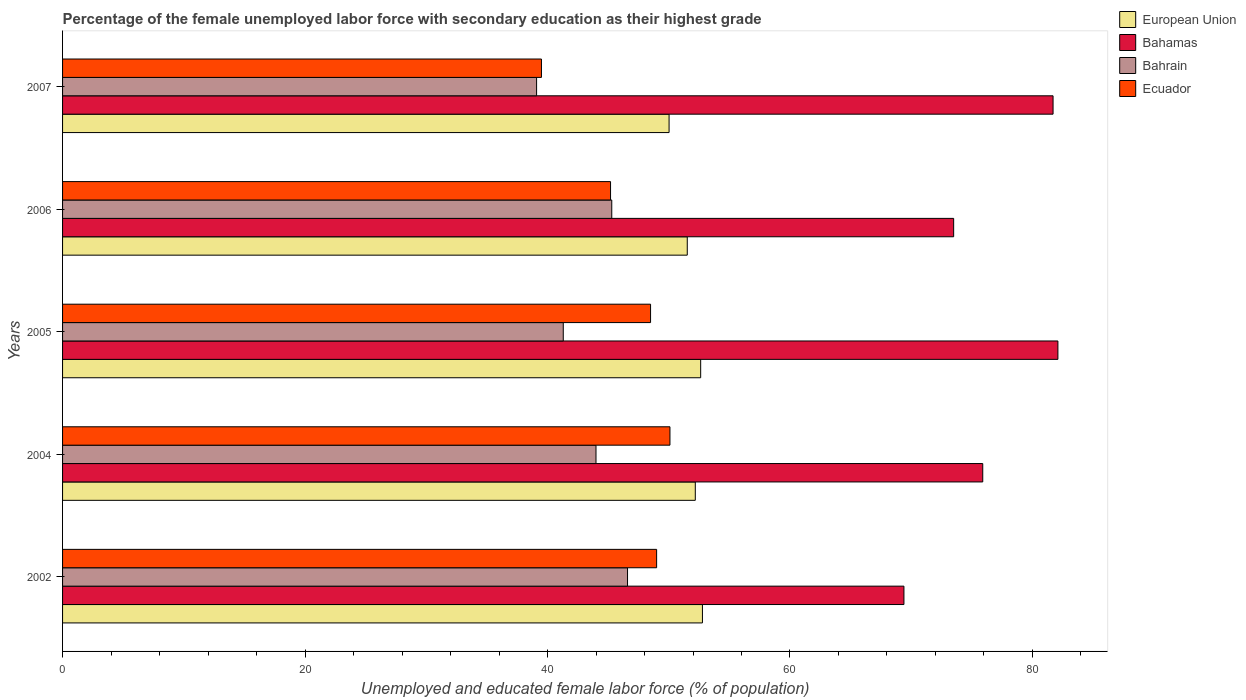How many different coloured bars are there?
Your answer should be compact. 4. Are the number of bars per tick equal to the number of legend labels?
Your response must be concise. Yes. How many bars are there on the 4th tick from the top?
Make the answer very short. 4. How many bars are there on the 3rd tick from the bottom?
Your answer should be very brief. 4. What is the label of the 3rd group of bars from the top?
Keep it short and to the point. 2005. In how many cases, is the number of bars for a given year not equal to the number of legend labels?
Keep it short and to the point. 0. What is the percentage of the unemployed female labor force with secondary education in Bahamas in 2004?
Your answer should be compact. 75.9. Across all years, what is the maximum percentage of the unemployed female labor force with secondary education in Bahamas?
Provide a succinct answer. 82.1. Across all years, what is the minimum percentage of the unemployed female labor force with secondary education in Bahrain?
Give a very brief answer. 39.1. In which year was the percentage of the unemployed female labor force with secondary education in Bahamas maximum?
Give a very brief answer. 2005. In which year was the percentage of the unemployed female labor force with secondary education in Bahrain minimum?
Offer a terse response. 2007. What is the total percentage of the unemployed female labor force with secondary education in European Union in the graph?
Keep it short and to the point. 259.16. What is the difference between the percentage of the unemployed female labor force with secondary education in European Union in 2005 and that in 2006?
Provide a succinct answer. 1.11. What is the difference between the percentage of the unemployed female labor force with secondary education in Bahrain in 2004 and the percentage of the unemployed female labor force with secondary education in European Union in 2007?
Keep it short and to the point. -6.03. What is the average percentage of the unemployed female labor force with secondary education in Bahamas per year?
Provide a succinct answer. 76.52. In the year 2004, what is the difference between the percentage of the unemployed female labor force with secondary education in Bahamas and percentage of the unemployed female labor force with secondary education in European Union?
Give a very brief answer. 23.71. In how many years, is the percentage of the unemployed female labor force with secondary education in Bahamas greater than 40 %?
Your response must be concise. 5. What is the ratio of the percentage of the unemployed female labor force with secondary education in European Union in 2004 to that in 2006?
Your answer should be compact. 1.01. Is the percentage of the unemployed female labor force with secondary education in European Union in 2002 less than that in 2005?
Your answer should be very brief. No. Is the difference between the percentage of the unemployed female labor force with secondary education in Bahamas in 2002 and 2005 greater than the difference between the percentage of the unemployed female labor force with secondary education in European Union in 2002 and 2005?
Provide a succinct answer. No. What is the difference between the highest and the second highest percentage of the unemployed female labor force with secondary education in Bahrain?
Make the answer very short. 1.3. What is the difference between the highest and the lowest percentage of the unemployed female labor force with secondary education in European Union?
Your answer should be compact. 2.75. In how many years, is the percentage of the unemployed female labor force with secondary education in Bahrain greater than the average percentage of the unemployed female labor force with secondary education in Bahrain taken over all years?
Provide a succinct answer. 3. What does the 2nd bar from the top in 2006 represents?
Make the answer very short. Bahrain. What does the 2nd bar from the bottom in 2005 represents?
Your answer should be compact. Bahamas. Are all the bars in the graph horizontal?
Your response must be concise. Yes. How many years are there in the graph?
Your answer should be compact. 5. What is the difference between two consecutive major ticks on the X-axis?
Make the answer very short. 20. Where does the legend appear in the graph?
Your answer should be compact. Top right. How many legend labels are there?
Make the answer very short. 4. How are the legend labels stacked?
Provide a short and direct response. Vertical. What is the title of the graph?
Your answer should be compact. Percentage of the female unemployed labor force with secondary education as their highest grade. Does "Luxembourg" appear as one of the legend labels in the graph?
Your response must be concise. No. What is the label or title of the X-axis?
Your answer should be compact. Unemployed and educated female labor force (% of population). What is the label or title of the Y-axis?
Your response must be concise. Years. What is the Unemployed and educated female labor force (% of population) of European Union in 2002?
Your answer should be very brief. 52.78. What is the Unemployed and educated female labor force (% of population) of Bahamas in 2002?
Offer a terse response. 69.4. What is the Unemployed and educated female labor force (% of population) in Bahrain in 2002?
Provide a succinct answer. 46.6. What is the Unemployed and educated female labor force (% of population) of Ecuador in 2002?
Your answer should be very brief. 49. What is the Unemployed and educated female labor force (% of population) of European Union in 2004?
Give a very brief answer. 52.19. What is the Unemployed and educated female labor force (% of population) of Bahamas in 2004?
Offer a very short reply. 75.9. What is the Unemployed and educated female labor force (% of population) of Bahrain in 2004?
Give a very brief answer. 44. What is the Unemployed and educated female labor force (% of population) of Ecuador in 2004?
Your answer should be very brief. 50.1. What is the Unemployed and educated female labor force (% of population) of European Union in 2005?
Offer a terse response. 52.63. What is the Unemployed and educated female labor force (% of population) of Bahamas in 2005?
Ensure brevity in your answer.  82.1. What is the Unemployed and educated female labor force (% of population) of Bahrain in 2005?
Provide a succinct answer. 41.3. What is the Unemployed and educated female labor force (% of population) in Ecuador in 2005?
Make the answer very short. 48.5. What is the Unemployed and educated female labor force (% of population) in European Union in 2006?
Offer a very short reply. 51.53. What is the Unemployed and educated female labor force (% of population) of Bahamas in 2006?
Provide a short and direct response. 73.5. What is the Unemployed and educated female labor force (% of population) of Bahrain in 2006?
Your answer should be very brief. 45.3. What is the Unemployed and educated female labor force (% of population) in Ecuador in 2006?
Your answer should be very brief. 45.2. What is the Unemployed and educated female labor force (% of population) of European Union in 2007?
Your answer should be very brief. 50.03. What is the Unemployed and educated female labor force (% of population) in Bahamas in 2007?
Offer a very short reply. 81.7. What is the Unemployed and educated female labor force (% of population) of Bahrain in 2007?
Your answer should be very brief. 39.1. What is the Unemployed and educated female labor force (% of population) of Ecuador in 2007?
Keep it short and to the point. 39.5. Across all years, what is the maximum Unemployed and educated female labor force (% of population) in European Union?
Provide a succinct answer. 52.78. Across all years, what is the maximum Unemployed and educated female labor force (% of population) of Bahamas?
Ensure brevity in your answer.  82.1. Across all years, what is the maximum Unemployed and educated female labor force (% of population) in Bahrain?
Ensure brevity in your answer.  46.6. Across all years, what is the maximum Unemployed and educated female labor force (% of population) in Ecuador?
Offer a very short reply. 50.1. Across all years, what is the minimum Unemployed and educated female labor force (% of population) of European Union?
Provide a short and direct response. 50.03. Across all years, what is the minimum Unemployed and educated female labor force (% of population) of Bahamas?
Your answer should be very brief. 69.4. Across all years, what is the minimum Unemployed and educated female labor force (% of population) in Bahrain?
Offer a terse response. 39.1. Across all years, what is the minimum Unemployed and educated female labor force (% of population) in Ecuador?
Give a very brief answer. 39.5. What is the total Unemployed and educated female labor force (% of population) of European Union in the graph?
Your answer should be compact. 259.16. What is the total Unemployed and educated female labor force (% of population) of Bahamas in the graph?
Your answer should be very brief. 382.6. What is the total Unemployed and educated female labor force (% of population) of Bahrain in the graph?
Offer a terse response. 216.3. What is the total Unemployed and educated female labor force (% of population) of Ecuador in the graph?
Your answer should be very brief. 232.3. What is the difference between the Unemployed and educated female labor force (% of population) in European Union in 2002 and that in 2004?
Keep it short and to the point. 0.59. What is the difference between the Unemployed and educated female labor force (% of population) of Bahamas in 2002 and that in 2004?
Ensure brevity in your answer.  -6.5. What is the difference between the Unemployed and educated female labor force (% of population) of Bahrain in 2002 and that in 2004?
Give a very brief answer. 2.6. What is the difference between the Unemployed and educated female labor force (% of population) in European Union in 2002 and that in 2005?
Provide a short and direct response. 0.15. What is the difference between the Unemployed and educated female labor force (% of population) of Bahrain in 2002 and that in 2005?
Your answer should be compact. 5.3. What is the difference between the Unemployed and educated female labor force (% of population) in Ecuador in 2002 and that in 2005?
Offer a very short reply. 0.5. What is the difference between the Unemployed and educated female labor force (% of population) in European Union in 2002 and that in 2006?
Provide a succinct answer. 1.25. What is the difference between the Unemployed and educated female labor force (% of population) in Ecuador in 2002 and that in 2006?
Your answer should be very brief. 3.8. What is the difference between the Unemployed and educated female labor force (% of population) of European Union in 2002 and that in 2007?
Your answer should be very brief. 2.75. What is the difference between the Unemployed and educated female labor force (% of population) in Bahamas in 2002 and that in 2007?
Offer a terse response. -12.3. What is the difference between the Unemployed and educated female labor force (% of population) in Bahrain in 2002 and that in 2007?
Offer a terse response. 7.5. What is the difference between the Unemployed and educated female labor force (% of population) of European Union in 2004 and that in 2005?
Keep it short and to the point. -0.44. What is the difference between the Unemployed and educated female labor force (% of population) of Bahamas in 2004 and that in 2005?
Your answer should be compact. -6.2. What is the difference between the Unemployed and educated female labor force (% of population) in Bahrain in 2004 and that in 2005?
Provide a succinct answer. 2.7. What is the difference between the Unemployed and educated female labor force (% of population) in European Union in 2004 and that in 2006?
Ensure brevity in your answer.  0.66. What is the difference between the Unemployed and educated female labor force (% of population) in Bahamas in 2004 and that in 2006?
Your answer should be compact. 2.4. What is the difference between the Unemployed and educated female labor force (% of population) in Ecuador in 2004 and that in 2006?
Your response must be concise. 4.9. What is the difference between the Unemployed and educated female labor force (% of population) of European Union in 2004 and that in 2007?
Provide a short and direct response. 2.16. What is the difference between the Unemployed and educated female labor force (% of population) in Bahamas in 2004 and that in 2007?
Offer a very short reply. -5.8. What is the difference between the Unemployed and educated female labor force (% of population) of Bahrain in 2004 and that in 2007?
Keep it short and to the point. 4.9. What is the difference between the Unemployed and educated female labor force (% of population) of European Union in 2005 and that in 2006?
Provide a succinct answer. 1.11. What is the difference between the Unemployed and educated female labor force (% of population) of Bahamas in 2005 and that in 2006?
Make the answer very short. 8.6. What is the difference between the Unemployed and educated female labor force (% of population) in Bahrain in 2005 and that in 2006?
Give a very brief answer. -4. What is the difference between the Unemployed and educated female labor force (% of population) of European Union in 2005 and that in 2007?
Ensure brevity in your answer.  2.61. What is the difference between the Unemployed and educated female labor force (% of population) of Bahamas in 2005 and that in 2007?
Your response must be concise. 0.4. What is the difference between the Unemployed and educated female labor force (% of population) in European Union in 2002 and the Unemployed and educated female labor force (% of population) in Bahamas in 2004?
Your answer should be compact. -23.12. What is the difference between the Unemployed and educated female labor force (% of population) in European Union in 2002 and the Unemployed and educated female labor force (% of population) in Bahrain in 2004?
Your answer should be very brief. 8.78. What is the difference between the Unemployed and educated female labor force (% of population) in European Union in 2002 and the Unemployed and educated female labor force (% of population) in Ecuador in 2004?
Give a very brief answer. 2.68. What is the difference between the Unemployed and educated female labor force (% of population) of Bahamas in 2002 and the Unemployed and educated female labor force (% of population) of Bahrain in 2004?
Ensure brevity in your answer.  25.4. What is the difference between the Unemployed and educated female labor force (% of population) in Bahamas in 2002 and the Unemployed and educated female labor force (% of population) in Ecuador in 2004?
Ensure brevity in your answer.  19.3. What is the difference between the Unemployed and educated female labor force (% of population) in European Union in 2002 and the Unemployed and educated female labor force (% of population) in Bahamas in 2005?
Your response must be concise. -29.32. What is the difference between the Unemployed and educated female labor force (% of population) of European Union in 2002 and the Unemployed and educated female labor force (% of population) of Bahrain in 2005?
Your answer should be compact. 11.48. What is the difference between the Unemployed and educated female labor force (% of population) in European Union in 2002 and the Unemployed and educated female labor force (% of population) in Ecuador in 2005?
Give a very brief answer. 4.28. What is the difference between the Unemployed and educated female labor force (% of population) in Bahamas in 2002 and the Unemployed and educated female labor force (% of population) in Bahrain in 2005?
Make the answer very short. 28.1. What is the difference between the Unemployed and educated female labor force (% of population) in Bahamas in 2002 and the Unemployed and educated female labor force (% of population) in Ecuador in 2005?
Give a very brief answer. 20.9. What is the difference between the Unemployed and educated female labor force (% of population) in Bahrain in 2002 and the Unemployed and educated female labor force (% of population) in Ecuador in 2005?
Ensure brevity in your answer.  -1.9. What is the difference between the Unemployed and educated female labor force (% of population) in European Union in 2002 and the Unemployed and educated female labor force (% of population) in Bahamas in 2006?
Offer a terse response. -20.72. What is the difference between the Unemployed and educated female labor force (% of population) in European Union in 2002 and the Unemployed and educated female labor force (% of population) in Bahrain in 2006?
Your answer should be very brief. 7.48. What is the difference between the Unemployed and educated female labor force (% of population) of European Union in 2002 and the Unemployed and educated female labor force (% of population) of Ecuador in 2006?
Your answer should be very brief. 7.58. What is the difference between the Unemployed and educated female labor force (% of population) in Bahamas in 2002 and the Unemployed and educated female labor force (% of population) in Bahrain in 2006?
Make the answer very short. 24.1. What is the difference between the Unemployed and educated female labor force (% of population) in Bahamas in 2002 and the Unemployed and educated female labor force (% of population) in Ecuador in 2006?
Your answer should be very brief. 24.2. What is the difference between the Unemployed and educated female labor force (% of population) of European Union in 2002 and the Unemployed and educated female labor force (% of population) of Bahamas in 2007?
Keep it short and to the point. -28.92. What is the difference between the Unemployed and educated female labor force (% of population) of European Union in 2002 and the Unemployed and educated female labor force (% of population) of Bahrain in 2007?
Your answer should be compact. 13.68. What is the difference between the Unemployed and educated female labor force (% of population) of European Union in 2002 and the Unemployed and educated female labor force (% of population) of Ecuador in 2007?
Ensure brevity in your answer.  13.28. What is the difference between the Unemployed and educated female labor force (% of population) of Bahamas in 2002 and the Unemployed and educated female labor force (% of population) of Bahrain in 2007?
Make the answer very short. 30.3. What is the difference between the Unemployed and educated female labor force (% of population) of Bahamas in 2002 and the Unemployed and educated female labor force (% of population) of Ecuador in 2007?
Offer a terse response. 29.9. What is the difference between the Unemployed and educated female labor force (% of population) of European Union in 2004 and the Unemployed and educated female labor force (% of population) of Bahamas in 2005?
Make the answer very short. -29.91. What is the difference between the Unemployed and educated female labor force (% of population) in European Union in 2004 and the Unemployed and educated female labor force (% of population) in Bahrain in 2005?
Your response must be concise. 10.89. What is the difference between the Unemployed and educated female labor force (% of population) in European Union in 2004 and the Unemployed and educated female labor force (% of population) in Ecuador in 2005?
Provide a succinct answer. 3.69. What is the difference between the Unemployed and educated female labor force (% of population) of Bahamas in 2004 and the Unemployed and educated female labor force (% of population) of Bahrain in 2005?
Your response must be concise. 34.6. What is the difference between the Unemployed and educated female labor force (% of population) of Bahamas in 2004 and the Unemployed and educated female labor force (% of population) of Ecuador in 2005?
Keep it short and to the point. 27.4. What is the difference between the Unemployed and educated female labor force (% of population) in Bahrain in 2004 and the Unemployed and educated female labor force (% of population) in Ecuador in 2005?
Ensure brevity in your answer.  -4.5. What is the difference between the Unemployed and educated female labor force (% of population) of European Union in 2004 and the Unemployed and educated female labor force (% of population) of Bahamas in 2006?
Give a very brief answer. -21.31. What is the difference between the Unemployed and educated female labor force (% of population) of European Union in 2004 and the Unemployed and educated female labor force (% of population) of Bahrain in 2006?
Your answer should be very brief. 6.89. What is the difference between the Unemployed and educated female labor force (% of population) in European Union in 2004 and the Unemployed and educated female labor force (% of population) in Ecuador in 2006?
Provide a succinct answer. 6.99. What is the difference between the Unemployed and educated female labor force (% of population) in Bahamas in 2004 and the Unemployed and educated female labor force (% of population) in Bahrain in 2006?
Your answer should be compact. 30.6. What is the difference between the Unemployed and educated female labor force (% of population) in Bahamas in 2004 and the Unemployed and educated female labor force (% of population) in Ecuador in 2006?
Offer a very short reply. 30.7. What is the difference between the Unemployed and educated female labor force (% of population) of European Union in 2004 and the Unemployed and educated female labor force (% of population) of Bahamas in 2007?
Keep it short and to the point. -29.51. What is the difference between the Unemployed and educated female labor force (% of population) of European Union in 2004 and the Unemployed and educated female labor force (% of population) of Bahrain in 2007?
Your answer should be very brief. 13.09. What is the difference between the Unemployed and educated female labor force (% of population) in European Union in 2004 and the Unemployed and educated female labor force (% of population) in Ecuador in 2007?
Offer a terse response. 12.69. What is the difference between the Unemployed and educated female labor force (% of population) in Bahamas in 2004 and the Unemployed and educated female labor force (% of population) in Bahrain in 2007?
Your answer should be very brief. 36.8. What is the difference between the Unemployed and educated female labor force (% of population) of Bahamas in 2004 and the Unemployed and educated female labor force (% of population) of Ecuador in 2007?
Provide a succinct answer. 36.4. What is the difference between the Unemployed and educated female labor force (% of population) of Bahrain in 2004 and the Unemployed and educated female labor force (% of population) of Ecuador in 2007?
Offer a terse response. 4.5. What is the difference between the Unemployed and educated female labor force (% of population) in European Union in 2005 and the Unemployed and educated female labor force (% of population) in Bahamas in 2006?
Your answer should be very brief. -20.87. What is the difference between the Unemployed and educated female labor force (% of population) of European Union in 2005 and the Unemployed and educated female labor force (% of population) of Bahrain in 2006?
Your answer should be compact. 7.33. What is the difference between the Unemployed and educated female labor force (% of population) of European Union in 2005 and the Unemployed and educated female labor force (% of population) of Ecuador in 2006?
Your response must be concise. 7.43. What is the difference between the Unemployed and educated female labor force (% of population) of Bahamas in 2005 and the Unemployed and educated female labor force (% of population) of Bahrain in 2006?
Provide a short and direct response. 36.8. What is the difference between the Unemployed and educated female labor force (% of population) of Bahamas in 2005 and the Unemployed and educated female labor force (% of population) of Ecuador in 2006?
Your response must be concise. 36.9. What is the difference between the Unemployed and educated female labor force (% of population) of Bahrain in 2005 and the Unemployed and educated female labor force (% of population) of Ecuador in 2006?
Your answer should be compact. -3.9. What is the difference between the Unemployed and educated female labor force (% of population) of European Union in 2005 and the Unemployed and educated female labor force (% of population) of Bahamas in 2007?
Provide a succinct answer. -29.07. What is the difference between the Unemployed and educated female labor force (% of population) in European Union in 2005 and the Unemployed and educated female labor force (% of population) in Bahrain in 2007?
Provide a short and direct response. 13.53. What is the difference between the Unemployed and educated female labor force (% of population) in European Union in 2005 and the Unemployed and educated female labor force (% of population) in Ecuador in 2007?
Offer a very short reply. 13.13. What is the difference between the Unemployed and educated female labor force (% of population) in Bahamas in 2005 and the Unemployed and educated female labor force (% of population) in Ecuador in 2007?
Keep it short and to the point. 42.6. What is the difference between the Unemployed and educated female labor force (% of population) of European Union in 2006 and the Unemployed and educated female labor force (% of population) of Bahamas in 2007?
Your answer should be very brief. -30.17. What is the difference between the Unemployed and educated female labor force (% of population) of European Union in 2006 and the Unemployed and educated female labor force (% of population) of Bahrain in 2007?
Your response must be concise. 12.43. What is the difference between the Unemployed and educated female labor force (% of population) in European Union in 2006 and the Unemployed and educated female labor force (% of population) in Ecuador in 2007?
Offer a terse response. 12.03. What is the difference between the Unemployed and educated female labor force (% of population) of Bahamas in 2006 and the Unemployed and educated female labor force (% of population) of Bahrain in 2007?
Keep it short and to the point. 34.4. What is the difference between the Unemployed and educated female labor force (% of population) in Bahamas in 2006 and the Unemployed and educated female labor force (% of population) in Ecuador in 2007?
Ensure brevity in your answer.  34. What is the average Unemployed and educated female labor force (% of population) in European Union per year?
Your response must be concise. 51.83. What is the average Unemployed and educated female labor force (% of population) in Bahamas per year?
Offer a very short reply. 76.52. What is the average Unemployed and educated female labor force (% of population) of Bahrain per year?
Give a very brief answer. 43.26. What is the average Unemployed and educated female labor force (% of population) in Ecuador per year?
Provide a succinct answer. 46.46. In the year 2002, what is the difference between the Unemployed and educated female labor force (% of population) of European Union and Unemployed and educated female labor force (% of population) of Bahamas?
Make the answer very short. -16.62. In the year 2002, what is the difference between the Unemployed and educated female labor force (% of population) of European Union and Unemployed and educated female labor force (% of population) of Bahrain?
Ensure brevity in your answer.  6.18. In the year 2002, what is the difference between the Unemployed and educated female labor force (% of population) in European Union and Unemployed and educated female labor force (% of population) in Ecuador?
Make the answer very short. 3.78. In the year 2002, what is the difference between the Unemployed and educated female labor force (% of population) in Bahamas and Unemployed and educated female labor force (% of population) in Bahrain?
Your answer should be compact. 22.8. In the year 2002, what is the difference between the Unemployed and educated female labor force (% of population) of Bahamas and Unemployed and educated female labor force (% of population) of Ecuador?
Your response must be concise. 20.4. In the year 2004, what is the difference between the Unemployed and educated female labor force (% of population) in European Union and Unemployed and educated female labor force (% of population) in Bahamas?
Your response must be concise. -23.71. In the year 2004, what is the difference between the Unemployed and educated female labor force (% of population) in European Union and Unemployed and educated female labor force (% of population) in Bahrain?
Ensure brevity in your answer.  8.19. In the year 2004, what is the difference between the Unemployed and educated female labor force (% of population) of European Union and Unemployed and educated female labor force (% of population) of Ecuador?
Offer a very short reply. 2.09. In the year 2004, what is the difference between the Unemployed and educated female labor force (% of population) in Bahamas and Unemployed and educated female labor force (% of population) in Bahrain?
Your answer should be compact. 31.9. In the year 2004, what is the difference between the Unemployed and educated female labor force (% of population) of Bahamas and Unemployed and educated female labor force (% of population) of Ecuador?
Keep it short and to the point. 25.8. In the year 2005, what is the difference between the Unemployed and educated female labor force (% of population) in European Union and Unemployed and educated female labor force (% of population) in Bahamas?
Provide a short and direct response. -29.47. In the year 2005, what is the difference between the Unemployed and educated female labor force (% of population) of European Union and Unemployed and educated female labor force (% of population) of Bahrain?
Provide a short and direct response. 11.33. In the year 2005, what is the difference between the Unemployed and educated female labor force (% of population) of European Union and Unemployed and educated female labor force (% of population) of Ecuador?
Ensure brevity in your answer.  4.13. In the year 2005, what is the difference between the Unemployed and educated female labor force (% of population) of Bahamas and Unemployed and educated female labor force (% of population) of Bahrain?
Provide a succinct answer. 40.8. In the year 2005, what is the difference between the Unemployed and educated female labor force (% of population) of Bahamas and Unemployed and educated female labor force (% of population) of Ecuador?
Keep it short and to the point. 33.6. In the year 2005, what is the difference between the Unemployed and educated female labor force (% of population) in Bahrain and Unemployed and educated female labor force (% of population) in Ecuador?
Your response must be concise. -7.2. In the year 2006, what is the difference between the Unemployed and educated female labor force (% of population) in European Union and Unemployed and educated female labor force (% of population) in Bahamas?
Your answer should be compact. -21.97. In the year 2006, what is the difference between the Unemployed and educated female labor force (% of population) of European Union and Unemployed and educated female labor force (% of population) of Bahrain?
Ensure brevity in your answer.  6.23. In the year 2006, what is the difference between the Unemployed and educated female labor force (% of population) in European Union and Unemployed and educated female labor force (% of population) in Ecuador?
Give a very brief answer. 6.33. In the year 2006, what is the difference between the Unemployed and educated female labor force (% of population) in Bahamas and Unemployed and educated female labor force (% of population) in Bahrain?
Your answer should be compact. 28.2. In the year 2006, what is the difference between the Unemployed and educated female labor force (% of population) of Bahamas and Unemployed and educated female labor force (% of population) of Ecuador?
Offer a very short reply. 28.3. In the year 2007, what is the difference between the Unemployed and educated female labor force (% of population) of European Union and Unemployed and educated female labor force (% of population) of Bahamas?
Provide a short and direct response. -31.67. In the year 2007, what is the difference between the Unemployed and educated female labor force (% of population) of European Union and Unemployed and educated female labor force (% of population) of Bahrain?
Your answer should be very brief. 10.93. In the year 2007, what is the difference between the Unemployed and educated female labor force (% of population) of European Union and Unemployed and educated female labor force (% of population) of Ecuador?
Ensure brevity in your answer.  10.53. In the year 2007, what is the difference between the Unemployed and educated female labor force (% of population) of Bahamas and Unemployed and educated female labor force (% of population) of Bahrain?
Your answer should be compact. 42.6. In the year 2007, what is the difference between the Unemployed and educated female labor force (% of population) of Bahamas and Unemployed and educated female labor force (% of population) of Ecuador?
Your response must be concise. 42.2. In the year 2007, what is the difference between the Unemployed and educated female labor force (% of population) in Bahrain and Unemployed and educated female labor force (% of population) in Ecuador?
Your response must be concise. -0.4. What is the ratio of the Unemployed and educated female labor force (% of population) of European Union in 2002 to that in 2004?
Make the answer very short. 1.01. What is the ratio of the Unemployed and educated female labor force (% of population) of Bahamas in 2002 to that in 2004?
Your answer should be compact. 0.91. What is the ratio of the Unemployed and educated female labor force (% of population) in Bahrain in 2002 to that in 2004?
Provide a succinct answer. 1.06. What is the ratio of the Unemployed and educated female labor force (% of population) of European Union in 2002 to that in 2005?
Provide a succinct answer. 1. What is the ratio of the Unemployed and educated female labor force (% of population) of Bahamas in 2002 to that in 2005?
Ensure brevity in your answer.  0.85. What is the ratio of the Unemployed and educated female labor force (% of population) in Bahrain in 2002 to that in 2005?
Keep it short and to the point. 1.13. What is the ratio of the Unemployed and educated female labor force (% of population) in Ecuador in 2002 to that in 2005?
Your answer should be very brief. 1.01. What is the ratio of the Unemployed and educated female labor force (% of population) of European Union in 2002 to that in 2006?
Offer a terse response. 1.02. What is the ratio of the Unemployed and educated female labor force (% of population) in Bahamas in 2002 to that in 2006?
Make the answer very short. 0.94. What is the ratio of the Unemployed and educated female labor force (% of population) of Bahrain in 2002 to that in 2006?
Provide a succinct answer. 1.03. What is the ratio of the Unemployed and educated female labor force (% of population) in Ecuador in 2002 to that in 2006?
Offer a very short reply. 1.08. What is the ratio of the Unemployed and educated female labor force (% of population) of European Union in 2002 to that in 2007?
Provide a succinct answer. 1.05. What is the ratio of the Unemployed and educated female labor force (% of population) in Bahamas in 2002 to that in 2007?
Provide a short and direct response. 0.85. What is the ratio of the Unemployed and educated female labor force (% of population) of Bahrain in 2002 to that in 2007?
Provide a succinct answer. 1.19. What is the ratio of the Unemployed and educated female labor force (% of population) in Ecuador in 2002 to that in 2007?
Give a very brief answer. 1.24. What is the ratio of the Unemployed and educated female labor force (% of population) of European Union in 2004 to that in 2005?
Provide a succinct answer. 0.99. What is the ratio of the Unemployed and educated female labor force (% of population) of Bahamas in 2004 to that in 2005?
Give a very brief answer. 0.92. What is the ratio of the Unemployed and educated female labor force (% of population) of Bahrain in 2004 to that in 2005?
Ensure brevity in your answer.  1.07. What is the ratio of the Unemployed and educated female labor force (% of population) of Ecuador in 2004 to that in 2005?
Ensure brevity in your answer.  1.03. What is the ratio of the Unemployed and educated female labor force (% of population) in European Union in 2004 to that in 2006?
Make the answer very short. 1.01. What is the ratio of the Unemployed and educated female labor force (% of population) of Bahamas in 2004 to that in 2006?
Offer a terse response. 1.03. What is the ratio of the Unemployed and educated female labor force (% of population) in Bahrain in 2004 to that in 2006?
Offer a very short reply. 0.97. What is the ratio of the Unemployed and educated female labor force (% of population) in Ecuador in 2004 to that in 2006?
Provide a succinct answer. 1.11. What is the ratio of the Unemployed and educated female labor force (% of population) of European Union in 2004 to that in 2007?
Offer a very short reply. 1.04. What is the ratio of the Unemployed and educated female labor force (% of population) of Bahamas in 2004 to that in 2007?
Provide a succinct answer. 0.93. What is the ratio of the Unemployed and educated female labor force (% of population) in Bahrain in 2004 to that in 2007?
Your answer should be compact. 1.13. What is the ratio of the Unemployed and educated female labor force (% of population) of Ecuador in 2004 to that in 2007?
Keep it short and to the point. 1.27. What is the ratio of the Unemployed and educated female labor force (% of population) in European Union in 2005 to that in 2006?
Provide a short and direct response. 1.02. What is the ratio of the Unemployed and educated female labor force (% of population) in Bahamas in 2005 to that in 2006?
Offer a terse response. 1.12. What is the ratio of the Unemployed and educated female labor force (% of population) of Bahrain in 2005 to that in 2006?
Provide a short and direct response. 0.91. What is the ratio of the Unemployed and educated female labor force (% of population) of Ecuador in 2005 to that in 2006?
Make the answer very short. 1.07. What is the ratio of the Unemployed and educated female labor force (% of population) of European Union in 2005 to that in 2007?
Your answer should be very brief. 1.05. What is the ratio of the Unemployed and educated female labor force (% of population) of Bahrain in 2005 to that in 2007?
Your answer should be very brief. 1.06. What is the ratio of the Unemployed and educated female labor force (% of population) in Ecuador in 2005 to that in 2007?
Provide a short and direct response. 1.23. What is the ratio of the Unemployed and educated female labor force (% of population) of European Union in 2006 to that in 2007?
Offer a terse response. 1.03. What is the ratio of the Unemployed and educated female labor force (% of population) of Bahamas in 2006 to that in 2007?
Your response must be concise. 0.9. What is the ratio of the Unemployed and educated female labor force (% of population) of Bahrain in 2006 to that in 2007?
Make the answer very short. 1.16. What is the ratio of the Unemployed and educated female labor force (% of population) of Ecuador in 2006 to that in 2007?
Offer a terse response. 1.14. What is the difference between the highest and the second highest Unemployed and educated female labor force (% of population) in European Union?
Provide a succinct answer. 0.15. What is the difference between the highest and the second highest Unemployed and educated female labor force (% of population) in Bahamas?
Your answer should be very brief. 0.4. What is the difference between the highest and the second highest Unemployed and educated female labor force (% of population) of Bahrain?
Ensure brevity in your answer.  1.3. What is the difference between the highest and the lowest Unemployed and educated female labor force (% of population) in European Union?
Offer a terse response. 2.75. What is the difference between the highest and the lowest Unemployed and educated female labor force (% of population) in Ecuador?
Ensure brevity in your answer.  10.6. 